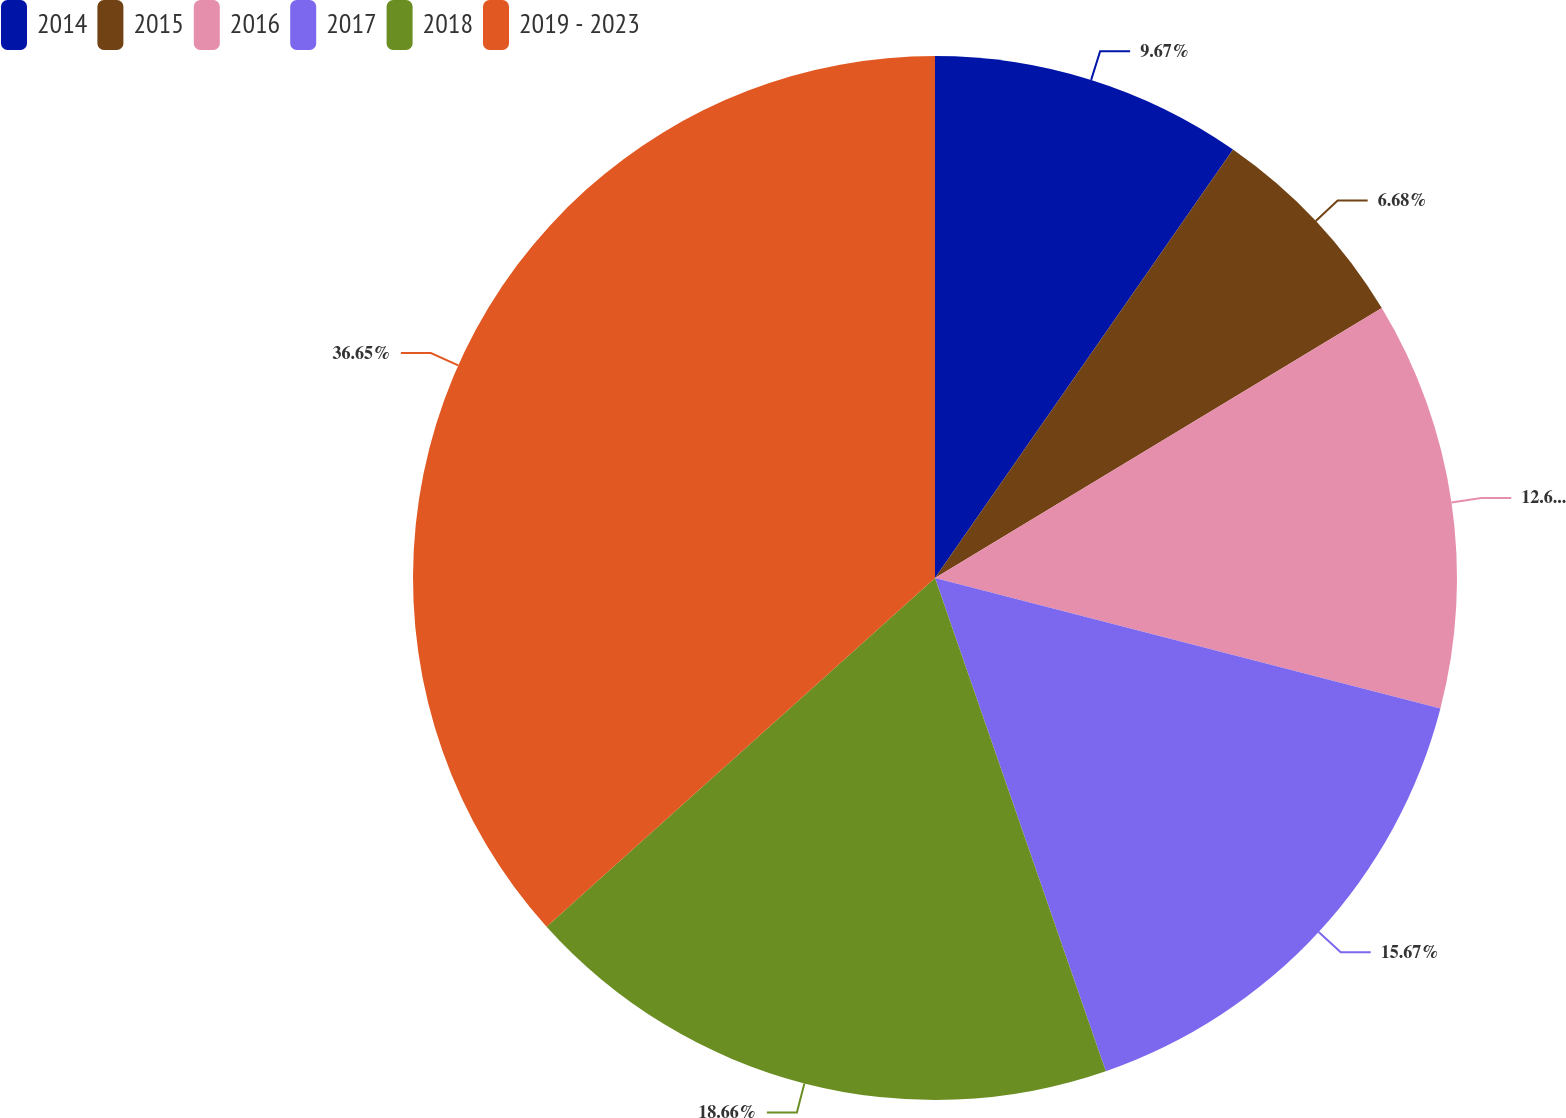<chart> <loc_0><loc_0><loc_500><loc_500><pie_chart><fcel>2014<fcel>2015<fcel>2016<fcel>2017<fcel>2018<fcel>2019 - 2023<nl><fcel>9.67%<fcel>6.68%<fcel>12.67%<fcel>15.67%<fcel>18.66%<fcel>36.64%<nl></chart> 